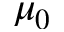Convert formula to latex. <formula><loc_0><loc_0><loc_500><loc_500>\mu _ { 0 }</formula> 